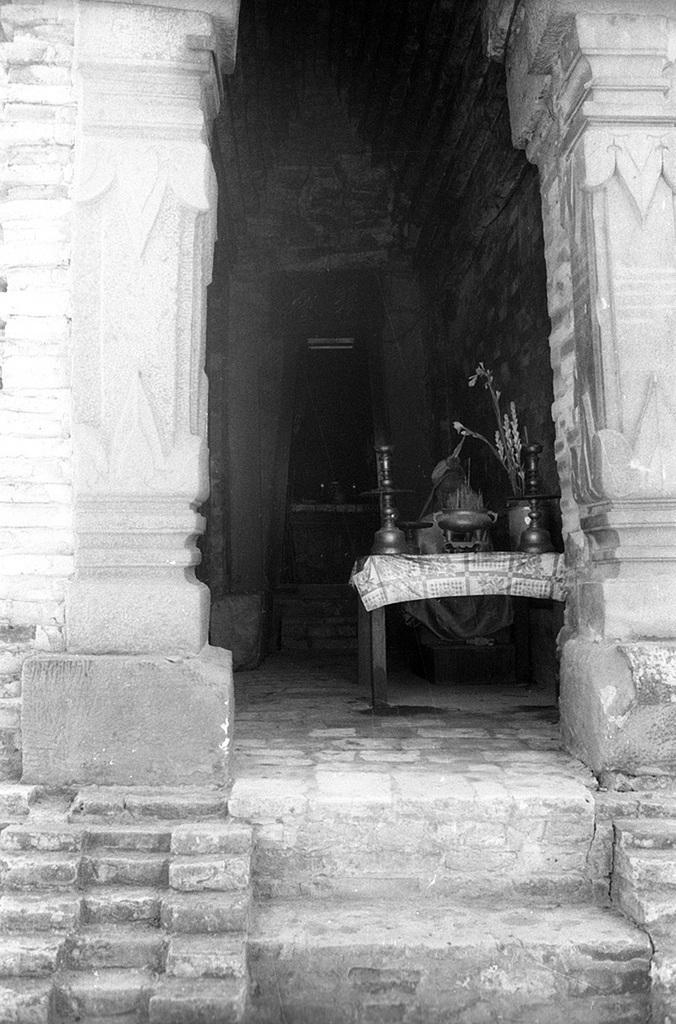Please provide a concise description of this image. This is a black and white picture. in this picture there are staircase and a building. In the center of the picture there is a table, on the table there are some steel utensils. In the background there is door. 